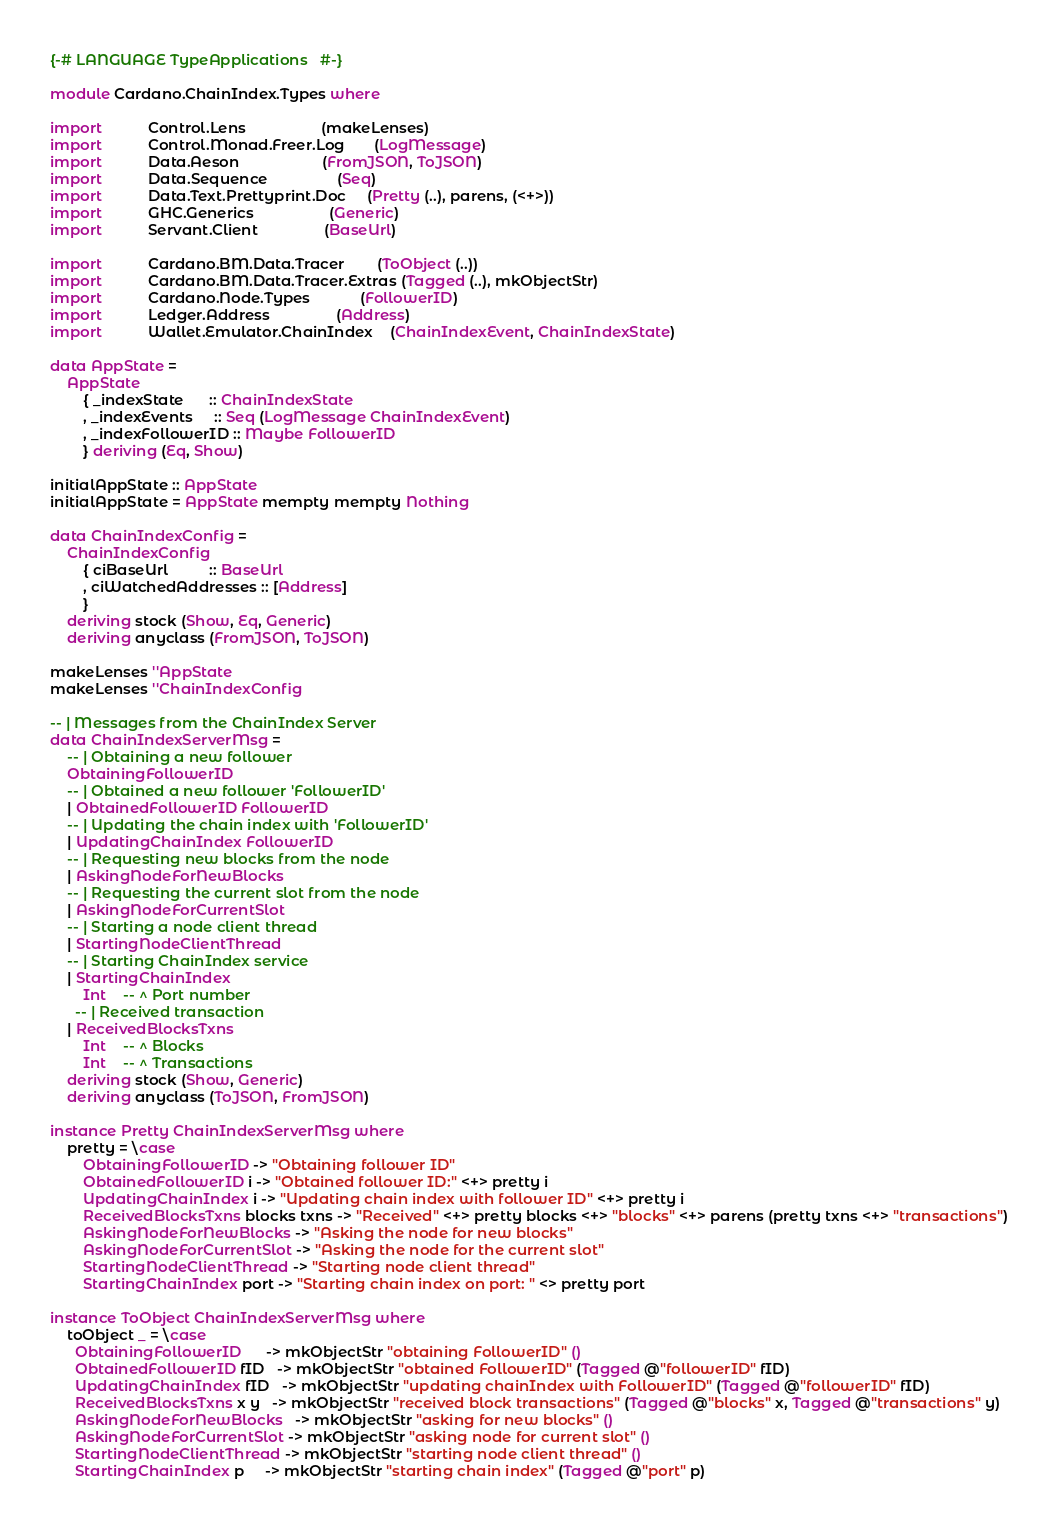<code> <loc_0><loc_0><loc_500><loc_500><_Haskell_>{-# LANGUAGE TypeApplications   #-}

module Cardano.ChainIndex.Types where

import           Control.Lens                  (makeLenses)
import           Control.Monad.Freer.Log       (LogMessage)
import           Data.Aeson                    (FromJSON, ToJSON)
import           Data.Sequence                 (Seq)
import           Data.Text.Prettyprint.Doc     (Pretty (..), parens, (<+>))
import           GHC.Generics                  (Generic)
import           Servant.Client                (BaseUrl)

import           Cardano.BM.Data.Tracer        (ToObject (..))
import           Cardano.BM.Data.Tracer.Extras (Tagged (..), mkObjectStr)
import           Cardano.Node.Types            (FollowerID)
import           Ledger.Address                (Address)
import           Wallet.Emulator.ChainIndex    (ChainIndexEvent, ChainIndexState)

data AppState =
    AppState
        { _indexState      :: ChainIndexState
        , _indexEvents     :: Seq (LogMessage ChainIndexEvent)
        , _indexFollowerID :: Maybe FollowerID
        } deriving (Eq, Show)

initialAppState :: AppState
initialAppState = AppState mempty mempty Nothing

data ChainIndexConfig =
    ChainIndexConfig
        { ciBaseUrl          :: BaseUrl
        , ciWatchedAddresses :: [Address]
        }
    deriving stock (Show, Eq, Generic)
    deriving anyclass (FromJSON, ToJSON)

makeLenses ''AppState
makeLenses ''ChainIndexConfig

-- | Messages from the ChainIndex Server
data ChainIndexServerMsg =
    -- | Obtaining a new follower
    ObtainingFollowerID
    -- | Obtained a new follower 'FollowerID'
    | ObtainedFollowerID FollowerID
    -- | Updating the chain index with 'FollowerID'
    | UpdatingChainIndex FollowerID
    -- | Requesting new blocks from the node
    | AskingNodeForNewBlocks
    -- | Requesting the current slot from the node
    | AskingNodeForCurrentSlot
    -- | Starting a node client thread
    | StartingNodeClientThread
    -- | Starting ChainIndex service
    | StartingChainIndex
        Int    -- ^ Port number
      -- | Received transaction
    | ReceivedBlocksTxns
        Int    -- ^ Blocks
        Int    -- ^ Transactions
    deriving stock (Show, Generic)
    deriving anyclass (ToJSON, FromJSON)

instance Pretty ChainIndexServerMsg where
    pretty = \case
        ObtainingFollowerID -> "Obtaining follower ID"
        ObtainedFollowerID i -> "Obtained follower ID:" <+> pretty i
        UpdatingChainIndex i -> "Updating chain index with follower ID" <+> pretty i
        ReceivedBlocksTxns blocks txns -> "Received" <+> pretty blocks <+> "blocks" <+> parens (pretty txns <+> "transactions")
        AskingNodeForNewBlocks -> "Asking the node for new blocks"
        AskingNodeForCurrentSlot -> "Asking the node for the current slot"
        StartingNodeClientThread -> "Starting node client thread"
        StartingChainIndex port -> "Starting chain index on port: " <> pretty port

instance ToObject ChainIndexServerMsg where
    toObject _ = \case
      ObtainingFollowerID      -> mkObjectStr "obtaining FollowerID" ()
      ObtainedFollowerID fID   -> mkObjectStr "obtained FollowerID" (Tagged @"followerID" fID)
      UpdatingChainIndex fID   -> mkObjectStr "updating chainIndex with FollowerID" (Tagged @"followerID" fID)
      ReceivedBlocksTxns x y   -> mkObjectStr "received block transactions" (Tagged @"blocks" x, Tagged @"transactions" y)
      AskingNodeForNewBlocks   -> mkObjectStr "asking for new blocks" ()
      AskingNodeForCurrentSlot -> mkObjectStr "asking node for current slot" ()
      StartingNodeClientThread -> mkObjectStr "starting node client thread" ()
      StartingChainIndex p     -> mkObjectStr "starting chain index" (Tagged @"port" p)
</code> 